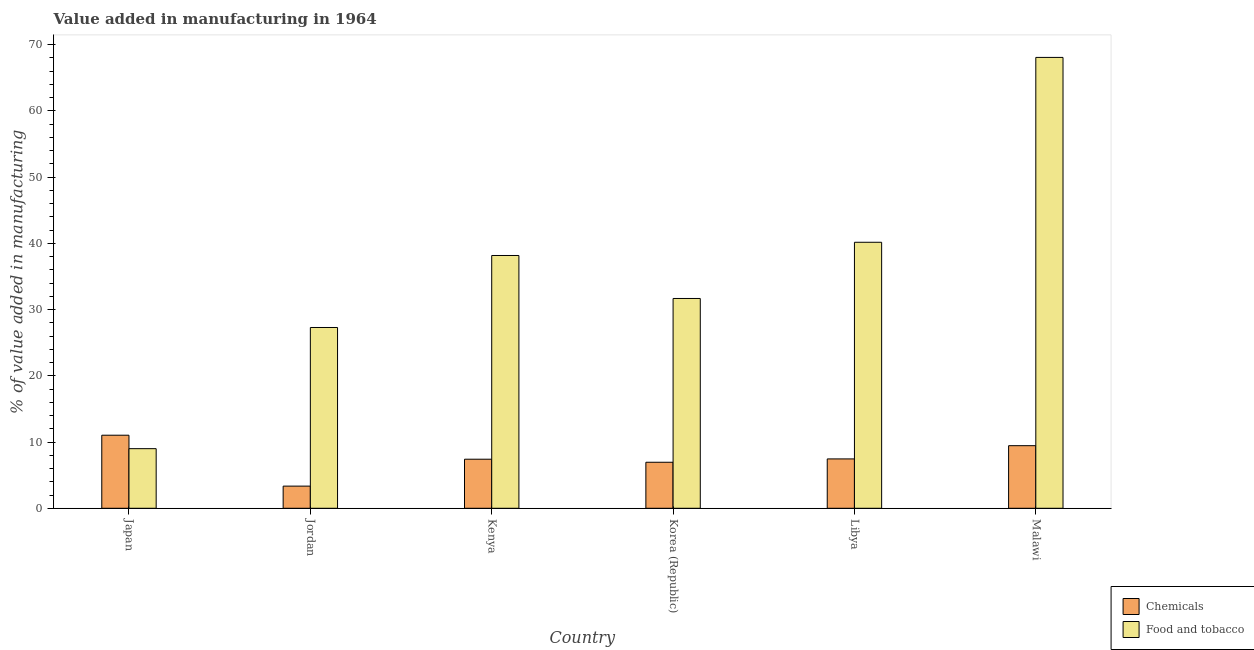How many different coloured bars are there?
Provide a succinct answer. 2. How many groups of bars are there?
Your answer should be very brief. 6. Are the number of bars per tick equal to the number of legend labels?
Ensure brevity in your answer.  Yes. How many bars are there on the 2nd tick from the left?
Offer a terse response. 2. How many bars are there on the 6th tick from the right?
Your response must be concise. 2. What is the label of the 6th group of bars from the left?
Keep it short and to the point. Malawi. In how many cases, is the number of bars for a given country not equal to the number of legend labels?
Your answer should be compact. 0. What is the value added by  manufacturing chemicals in Malawi?
Your response must be concise. 9.45. Across all countries, what is the maximum value added by  manufacturing chemicals?
Make the answer very short. 11.03. Across all countries, what is the minimum value added by  manufacturing chemicals?
Ensure brevity in your answer.  3.34. In which country was the value added by manufacturing food and tobacco maximum?
Provide a short and direct response. Malawi. What is the total value added by manufacturing food and tobacco in the graph?
Offer a terse response. 214.39. What is the difference between the value added by  manufacturing chemicals in Japan and that in Korea (Republic)?
Your answer should be compact. 4.08. What is the difference between the value added by  manufacturing chemicals in Kenya and the value added by manufacturing food and tobacco in Malawi?
Your answer should be very brief. -60.67. What is the average value added by  manufacturing chemicals per country?
Your response must be concise. 7.61. What is the difference between the value added by  manufacturing chemicals and value added by manufacturing food and tobacco in Libya?
Provide a short and direct response. -32.71. In how many countries, is the value added by  manufacturing chemicals greater than 12 %?
Offer a terse response. 0. What is the ratio of the value added by  manufacturing chemicals in Jordan to that in Korea (Republic)?
Provide a succinct answer. 0.48. Is the value added by manufacturing food and tobacco in Japan less than that in Malawi?
Offer a very short reply. Yes. Is the difference between the value added by  manufacturing chemicals in Jordan and Korea (Republic) greater than the difference between the value added by manufacturing food and tobacco in Jordan and Korea (Republic)?
Your answer should be very brief. Yes. What is the difference between the highest and the second highest value added by  manufacturing chemicals?
Provide a succinct answer. 1.58. What is the difference between the highest and the lowest value added by  manufacturing chemicals?
Your answer should be very brief. 7.69. What does the 2nd bar from the left in Jordan represents?
Your answer should be very brief. Food and tobacco. What does the 1st bar from the right in Korea (Republic) represents?
Your answer should be very brief. Food and tobacco. How many bars are there?
Make the answer very short. 12. Are all the bars in the graph horizontal?
Provide a succinct answer. No. How many countries are there in the graph?
Make the answer very short. 6. What is the difference between two consecutive major ticks on the Y-axis?
Ensure brevity in your answer.  10. Are the values on the major ticks of Y-axis written in scientific E-notation?
Provide a succinct answer. No. Does the graph contain any zero values?
Provide a succinct answer. No. How are the legend labels stacked?
Your answer should be very brief. Vertical. What is the title of the graph?
Your answer should be very brief. Value added in manufacturing in 1964. What is the label or title of the Y-axis?
Make the answer very short. % of value added in manufacturing. What is the % of value added in manufacturing of Chemicals in Japan?
Provide a succinct answer. 11.03. What is the % of value added in manufacturing in Food and tobacco in Japan?
Offer a very short reply. 9. What is the % of value added in manufacturing in Chemicals in Jordan?
Offer a terse response. 3.34. What is the % of value added in manufacturing in Food and tobacco in Jordan?
Give a very brief answer. 27.3. What is the % of value added in manufacturing in Chemicals in Kenya?
Offer a terse response. 7.41. What is the % of value added in manufacturing of Food and tobacco in Kenya?
Your response must be concise. 38.17. What is the % of value added in manufacturing of Chemicals in Korea (Republic)?
Your answer should be compact. 6.95. What is the % of value added in manufacturing of Food and tobacco in Korea (Republic)?
Keep it short and to the point. 31.68. What is the % of value added in manufacturing in Chemicals in Libya?
Provide a succinct answer. 7.45. What is the % of value added in manufacturing of Food and tobacco in Libya?
Provide a short and direct response. 40.17. What is the % of value added in manufacturing in Chemicals in Malawi?
Make the answer very short. 9.45. What is the % of value added in manufacturing of Food and tobacco in Malawi?
Offer a very short reply. 68.08. Across all countries, what is the maximum % of value added in manufacturing in Chemicals?
Make the answer very short. 11.03. Across all countries, what is the maximum % of value added in manufacturing in Food and tobacco?
Provide a short and direct response. 68.08. Across all countries, what is the minimum % of value added in manufacturing in Chemicals?
Make the answer very short. 3.34. Across all countries, what is the minimum % of value added in manufacturing in Food and tobacco?
Your answer should be compact. 9. What is the total % of value added in manufacturing in Chemicals in the graph?
Offer a very short reply. 45.64. What is the total % of value added in manufacturing in Food and tobacco in the graph?
Your response must be concise. 214.39. What is the difference between the % of value added in manufacturing of Chemicals in Japan and that in Jordan?
Your response must be concise. 7.69. What is the difference between the % of value added in manufacturing of Food and tobacco in Japan and that in Jordan?
Your answer should be very brief. -18.3. What is the difference between the % of value added in manufacturing in Chemicals in Japan and that in Kenya?
Your answer should be very brief. 3.62. What is the difference between the % of value added in manufacturing in Food and tobacco in Japan and that in Kenya?
Give a very brief answer. -29.17. What is the difference between the % of value added in manufacturing of Chemicals in Japan and that in Korea (Republic)?
Ensure brevity in your answer.  4.08. What is the difference between the % of value added in manufacturing in Food and tobacco in Japan and that in Korea (Republic)?
Your answer should be very brief. -22.68. What is the difference between the % of value added in manufacturing of Chemicals in Japan and that in Libya?
Ensure brevity in your answer.  3.58. What is the difference between the % of value added in manufacturing of Food and tobacco in Japan and that in Libya?
Provide a succinct answer. -31.17. What is the difference between the % of value added in manufacturing of Chemicals in Japan and that in Malawi?
Your answer should be very brief. 1.58. What is the difference between the % of value added in manufacturing of Food and tobacco in Japan and that in Malawi?
Your response must be concise. -59.08. What is the difference between the % of value added in manufacturing in Chemicals in Jordan and that in Kenya?
Offer a terse response. -4.06. What is the difference between the % of value added in manufacturing in Food and tobacco in Jordan and that in Kenya?
Your answer should be very brief. -10.87. What is the difference between the % of value added in manufacturing in Chemicals in Jordan and that in Korea (Republic)?
Offer a very short reply. -3.6. What is the difference between the % of value added in manufacturing in Food and tobacco in Jordan and that in Korea (Republic)?
Ensure brevity in your answer.  -4.38. What is the difference between the % of value added in manufacturing of Chemicals in Jordan and that in Libya?
Ensure brevity in your answer.  -4.11. What is the difference between the % of value added in manufacturing of Food and tobacco in Jordan and that in Libya?
Offer a very short reply. -12.87. What is the difference between the % of value added in manufacturing of Chemicals in Jordan and that in Malawi?
Your answer should be compact. -6.11. What is the difference between the % of value added in manufacturing of Food and tobacco in Jordan and that in Malawi?
Provide a short and direct response. -40.78. What is the difference between the % of value added in manufacturing in Chemicals in Kenya and that in Korea (Republic)?
Offer a very short reply. 0.46. What is the difference between the % of value added in manufacturing of Food and tobacco in Kenya and that in Korea (Republic)?
Provide a short and direct response. 6.49. What is the difference between the % of value added in manufacturing of Chemicals in Kenya and that in Libya?
Give a very brief answer. -0.05. What is the difference between the % of value added in manufacturing in Food and tobacco in Kenya and that in Libya?
Ensure brevity in your answer.  -2. What is the difference between the % of value added in manufacturing of Chemicals in Kenya and that in Malawi?
Make the answer very short. -2.04. What is the difference between the % of value added in manufacturing of Food and tobacco in Kenya and that in Malawi?
Ensure brevity in your answer.  -29.91. What is the difference between the % of value added in manufacturing in Chemicals in Korea (Republic) and that in Libya?
Provide a short and direct response. -0.51. What is the difference between the % of value added in manufacturing in Food and tobacco in Korea (Republic) and that in Libya?
Offer a terse response. -8.49. What is the difference between the % of value added in manufacturing in Chemicals in Korea (Republic) and that in Malawi?
Provide a succinct answer. -2.5. What is the difference between the % of value added in manufacturing in Food and tobacco in Korea (Republic) and that in Malawi?
Make the answer very short. -36.4. What is the difference between the % of value added in manufacturing in Chemicals in Libya and that in Malawi?
Provide a succinct answer. -2. What is the difference between the % of value added in manufacturing of Food and tobacco in Libya and that in Malawi?
Provide a short and direct response. -27.91. What is the difference between the % of value added in manufacturing in Chemicals in Japan and the % of value added in manufacturing in Food and tobacco in Jordan?
Give a very brief answer. -16.27. What is the difference between the % of value added in manufacturing of Chemicals in Japan and the % of value added in manufacturing of Food and tobacco in Kenya?
Offer a very short reply. -27.14. What is the difference between the % of value added in manufacturing in Chemicals in Japan and the % of value added in manufacturing in Food and tobacco in Korea (Republic)?
Keep it short and to the point. -20.65. What is the difference between the % of value added in manufacturing in Chemicals in Japan and the % of value added in manufacturing in Food and tobacco in Libya?
Offer a very short reply. -29.13. What is the difference between the % of value added in manufacturing of Chemicals in Japan and the % of value added in manufacturing of Food and tobacco in Malawi?
Your answer should be very brief. -57.05. What is the difference between the % of value added in manufacturing of Chemicals in Jordan and the % of value added in manufacturing of Food and tobacco in Kenya?
Offer a very short reply. -34.82. What is the difference between the % of value added in manufacturing of Chemicals in Jordan and the % of value added in manufacturing of Food and tobacco in Korea (Republic)?
Your answer should be compact. -28.33. What is the difference between the % of value added in manufacturing in Chemicals in Jordan and the % of value added in manufacturing in Food and tobacco in Libya?
Your answer should be very brief. -36.82. What is the difference between the % of value added in manufacturing in Chemicals in Jordan and the % of value added in manufacturing in Food and tobacco in Malawi?
Keep it short and to the point. -64.73. What is the difference between the % of value added in manufacturing of Chemicals in Kenya and the % of value added in manufacturing of Food and tobacco in Korea (Republic)?
Offer a terse response. -24.27. What is the difference between the % of value added in manufacturing of Chemicals in Kenya and the % of value added in manufacturing of Food and tobacco in Libya?
Give a very brief answer. -32.76. What is the difference between the % of value added in manufacturing of Chemicals in Kenya and the % of value added in manufacturing of Food and tobacco in Malawi?
Your answer should be very brief. -60.67. What is the difference between the % of value added in manufacturing in Chemicals in Korea (Republic) and the % of value added in manufacturing in Food and tobacco in Libya?
Your answer should be compact. -33.22. What is the difference between the % of value added in manufacturing of Chemicals in Korea (Republic) and the % of value added in manufacturing of Food and tobacco in Malawi?
Your answer should be compact. -61.13. What is the difference between the % of value added in manufacturing of Chemicals in Libya and the % of value added in manufacturing of Food and tobacco in Malawi?
Provide a succinct answer. -60.62. What is the average % of value added in manufacturing in Chemicals per country?
Offer a terse response. 7.61. What is the average % of value added in manufacturing of Food and tobacco per country?
Make the answer very short. 35.73. What is the difference between the % of value added in manufacturing of Chemicals and % of value added in manufacturing of Food and tobacco in Japan?
Make the answer very short. 2.03. What is the difference between the % of value added in manufacturing of Chemicals and % of value added in manufacturing of Food and tobacco in Jordan?
Ensure brevity in your answer.  -23.95. What is the difference between the % of value added in manufacturing of Chemicals and % of value added in manufacturing of Food and tobacco in Kenya?
Offer a very short reply. -30.76. What is the difference between the % of value added in manufacturing in Chemicals and % of value added in manufacturing in Food and tobacco in Korea (Republic)?
Provide a succinct answer. -24.73. What is the difference between the % of value added in manufacturing of Chemicals and % of value added in manufacturing of Food and tobacco in Libya?
Offer a very short reply. -32.71. What is the difference between the % of value added in manufacturing of Chemicals and % of value added in manufacturing of Food and tobacco in Malawi?
Your answer should be compact. -58.63. What is the ratio of the % of value added in manufacturing of Chemicals in Japan to that in Jordan?
Give a very brief answer. 3.3. What is the ratio of the % of value added in manufacturing of Food and tobacco in Japan to that in Jordan?
Keep it short and to the point. 0.33. What is the ratio of the % of value added in manufacturing in Chemicals in Japan to that in Kenya?
Give a very brief answer. 1.49. What is the ratio of the % of value added in manufacturing in Food and tobacco in Japan to that in Kenya?
Provide a short and direct response. 0.24. What is the ratio of the % of value added in manufacturing in Chemicals in Japan to that in Korea (Republic)?
Give a very brief answer. 1.59. What is the ratio of the % of value added in manufacturing in Food and tobacco in Japan to that in Korea (Republic)?
Offer a very short reply. 0.28. What is the ratio of the % of value added in manufacturing in Chemicals in Japan to that in Libya?
Your answer should be very brief. 1.48. What is the ratio of the % of value added in manufacturing in Food and tobacco in Japan to that in Libya?
Offer a very short reply. 0.22. What is the ratio of the % of value added in manufacturing of Chemicals in Japan to that in Malawi?
Provide a short and direct response. 1.17. What is the ratio of the % of value added in manufacturing of Food and tobacco in Japan to that in Malawi?
Ensure brevity in your answer.  0.13. What is the ratio of the % of value added in manufacturing in Chemicals in Jordan to that in Kenya?
Offer a very short reply. 0.45. What is the ratio of the % of value added in manufacturing of Food and tobacco in Jordan to that in Kenya?
Offer a terse response. 0.72. What is the ratio of the % of value added in manufacturing of Chemicals in Jordan to that in Korea (Republic)?
Your response must be concise. 0.48. What is the ratio of the % of value added in manufacturing of Food and tobacco in Jordan to that in Korea (Republic)?
Provide a short and direct response. 0.86. What is the ratio of the % of value added in manufacturing in Chemicals in Jordan to that in Libya?
Your response must be concise. 0.45. What is the ratio of the % of value added in manufacturing of Food and tobacco in Jordan to that in Libya?
Offer a very short reply. 0.68. What is the ratio of the % of value added in manufacturing of Chemicals in Jordan to that in Malawi?
Provide a succinct answer. 0.35. What is the ratio of the % of value added in manufacturing in Food and tobacco in Jordan to that in Malawi?
Keep it short and to the point. 0.4. What is the ratio of the % of value added in manufacturing of Chemicals in Kenya to that in Korea (Republic)?
Provide a short and direct response. 1.07. What is the ratio of the % of value added in manufacturing of Food and tobacco in Kenya to that in Korea (Republic)?
Give a very brief answer. 1.2. What is the ratio of the % of value added in manufacturing in Food and tobacco in Kenya to that in Libya?
Give a very brief answer. 0.95. What is the ratio of the % of value added in manufacturing in Chemicals in Kenya to that in Malawi?
Make the answer very short. 0.78. What is the ratio of the % of value added in manufacturing of Food and tobacco in Kenya to that in Malawi?
Give a very brief answer. 0.56. What is the ratio of the % of value added in manufacturing of Chemicals in Korea (Republic) to that in Libya?
Offer a very short reply. 0.93. What is the ratio of the % of value added in manufacturing of Food and tobacco in Korea (Republic) to that in Libya?
Your answer should be compact. 0.79. What is the ratio of the % of value added in manufacturing in Chemicals in Korea (Republic) to that in Malawi?
Your answer should be very brief. 0.74. What is the ratio of the % of value added in manufacturing of Food and tobacco in Korea (Republic) to that in Malawi?
Provide a succinct answer. 0.47. What is the ratio of the % of value added in manufacturing of Chemicals in Libya to that in Malawi?
Ensure brevity in your answer.  0.79. What is the ratio of the % of value added in manufacturing of Food and tobacco in Libya to that in Malawi?
Your response must be concise. 0.59. What is the difference between the highest and the second highest % of value added in manufacturing of Chemicals?
Ensure brevity in your answer.  1.58. What is the difference between the highest and the second highest % of value added in manufacturing in Food and tobacco?
Offer a terse response. 27.91. What is the difference between the highest and the lowest % of value added in manufacturing in Chemicals?
Your response must be concise. 7.69. What is the difference between the highest and the lowest % of value added in manufacturing of Food and tobacco?
Provide a succinct answer. 59.08. 